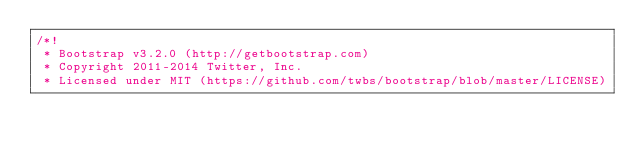<code> <loc_0><loc_0><loc_500><loc_500><_CSS_>/*!
 * Bootstrap v3.2.0 (http://getbootstrap.com)
 * Copyright 2011-2014 Twitter, Inc.
 * Licensed under MIT (https://github.com/twbs/bootstrap/blob/master/LICENSE)</code> 